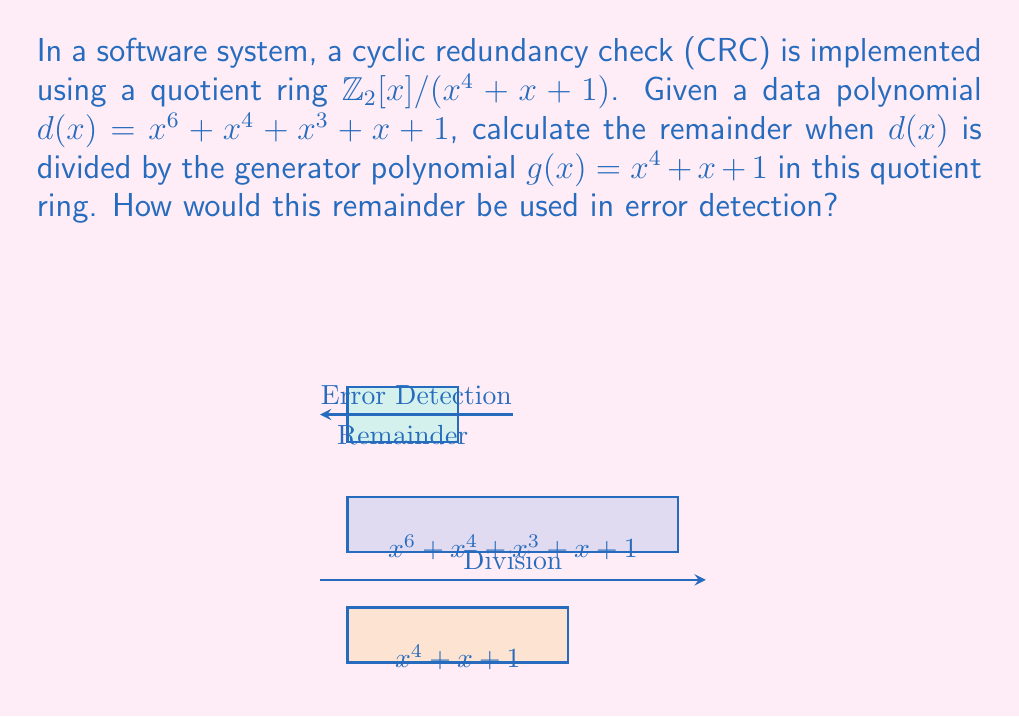Could you help me with this problem? To solve this problem, we need to follow these steps:

1) First, we need to perform polynomial division of $d(x)$ by $g(x)$ in $\mathbb{Z}_2[x]$:

   $x^6 + x^4 + x^3 + x + 1 = (x^2 + x + 1)(x^4 + x + 1) + (x^2 + 1)$

2) The remainder is $r(x) = x^2 + 1$

3) In the quotient ring $\mathbb{Z}_2[x]/(x^4 + x + 1)$, this remainder represents the error detection code.

4) For error detection:
   - The sender would transmit both the data polynomial $d(x)$ and the remainder $r(x)$.
   - The receiver would divide the received data polynomial by $g(x)$ and compare the calculated remainder with the received remainder.
   - If they match, no error is detected. If they differ, an error is detected.

5) The use of a quotient ring in this context allows for efficient computation and representation of the remainders, as all operations are performed modulo the generator polynomial $g(x) = x^4 + x + 1$.

6) This method can detect all single-bit errors and all burst errors up to the length of the generator polynomial (in this case, 4 bits).
Answer: $x^2 + 1$ 